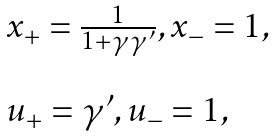<formula> <loc_0><loc_0><loc_500><loc_500>\begin{array} { l l l } x _ { + } = \frac { 1 } { 1 + \gamma \gamma ^ { \prime } } , x _ { - } = 1 , \\ \\ u _ { + } = \gamma ^ { \prime } , u _ { - } = 1 , \end{array}</formula> 